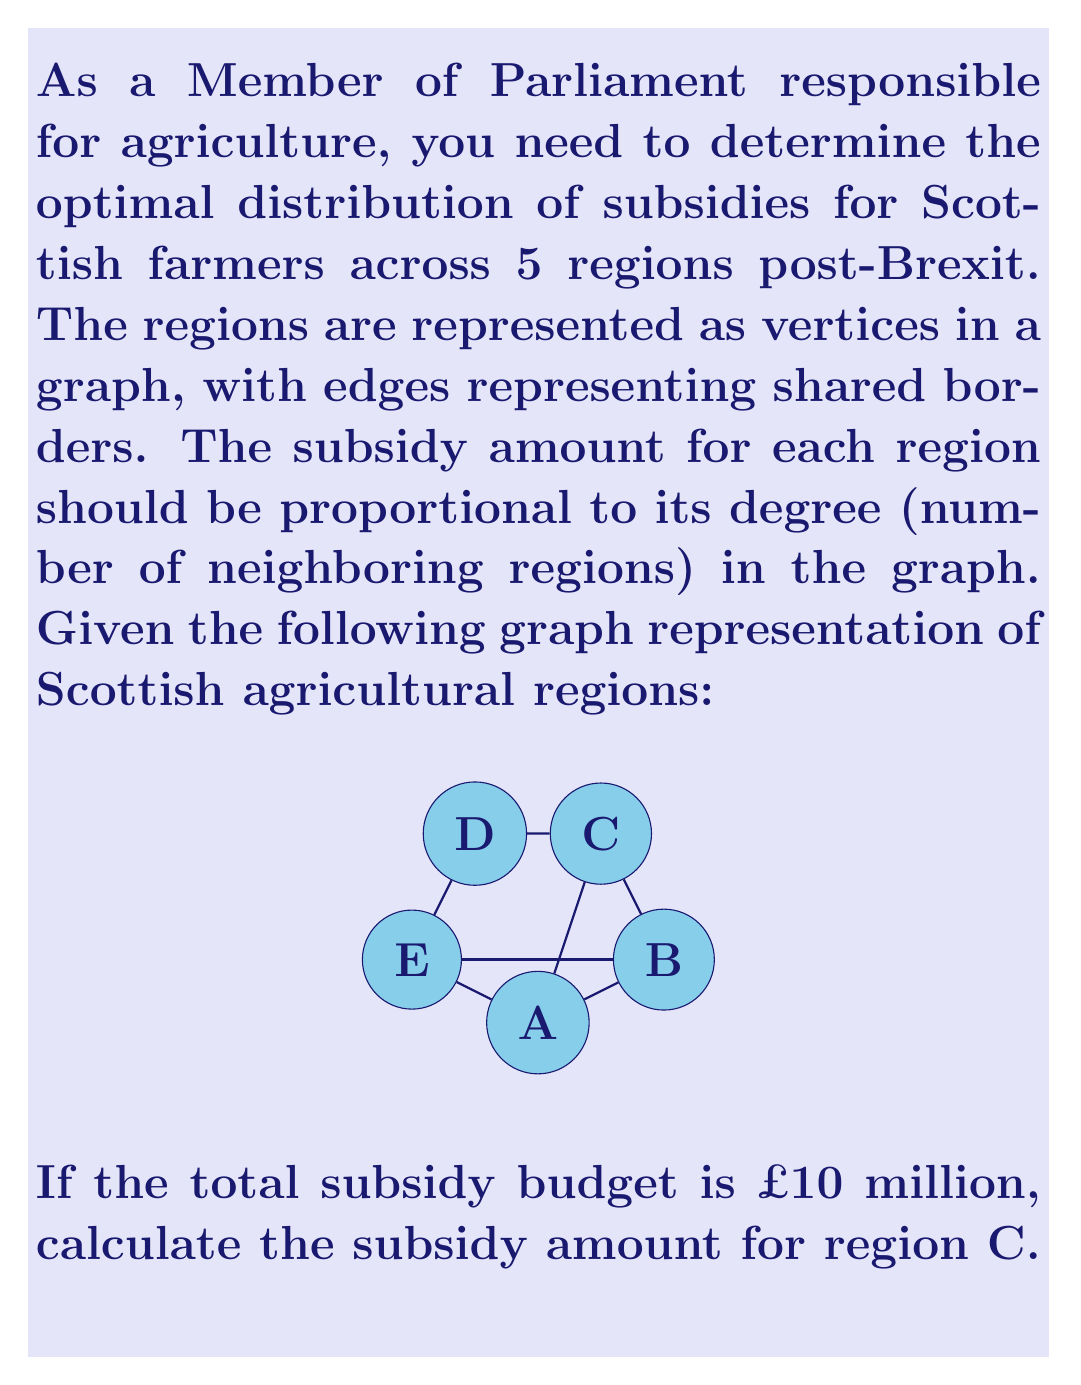Teach me how to tackle this problem. To solve this problem, we'll follow these steps:

1. Determine the degree of each vertex (region) in the graph:
   Region A: degree 3
   Region B: degree 3
   Region C: degree 4
   Region D: degree 2
   Region E: degree 3

2. Calculate the total degree sum:
   $$\text{Total degree} = 3 + 3 + 4 + 2 + 3 = 15$$

3. Set up the proportion for region C:
   Let x be the subsidy amount for region C.
   $$\frac{x}{\text{Total budget}} = \frac{\text{Degree of C}}{\text{Total degree}}$$

4. Substitute the known values:
   $$\frac{x}{10,000,000} = \frac{4}{15}$$

5. Solve for x:
   $$x = 10,000,000 \cdot \frac{4}{15} = \frac{40,000,000}{15} = 2,666,666.67$$

Therefore, the subsidy amount for region C is £2,666,666.67 (rounded to the nearest penny).
Answer: £2,666,666.67 